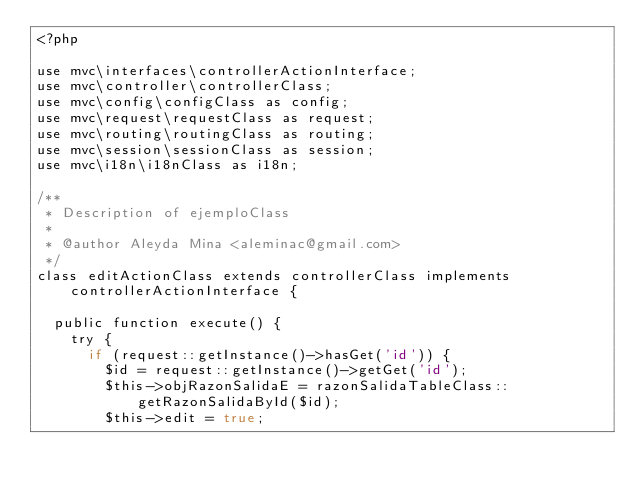<code> <loc_0><loc_0><loc_500><loc_500><_PHP_><?php

use mvc\interfaces\controllerActionInterface;
use mvc\controller\controllerClass;
use mvc\config\configClass as config;
use mvc\request\requestClass as request;
use mvc\routing\routingClass as routing;
use mvc\session\sessionClass as session;
use mvc\i18n\i18nClass as i18n;

/**
 * Description of ejemploClass
 *
 * @author Aleyda Mina <aleminac@gmail.com>
 */
class editActionClass extends controllerClass implements controllerActionInterface {

  public function execute() {
    try {
      if (request::getInstance()->hasGet('id')) {
        $id = request::getInstance()->getGet('id');
        $this->objRazonSalidaE = razonSalidaTableClass::getRazonSalidaById($id);
        $this->edit = true;</code> 